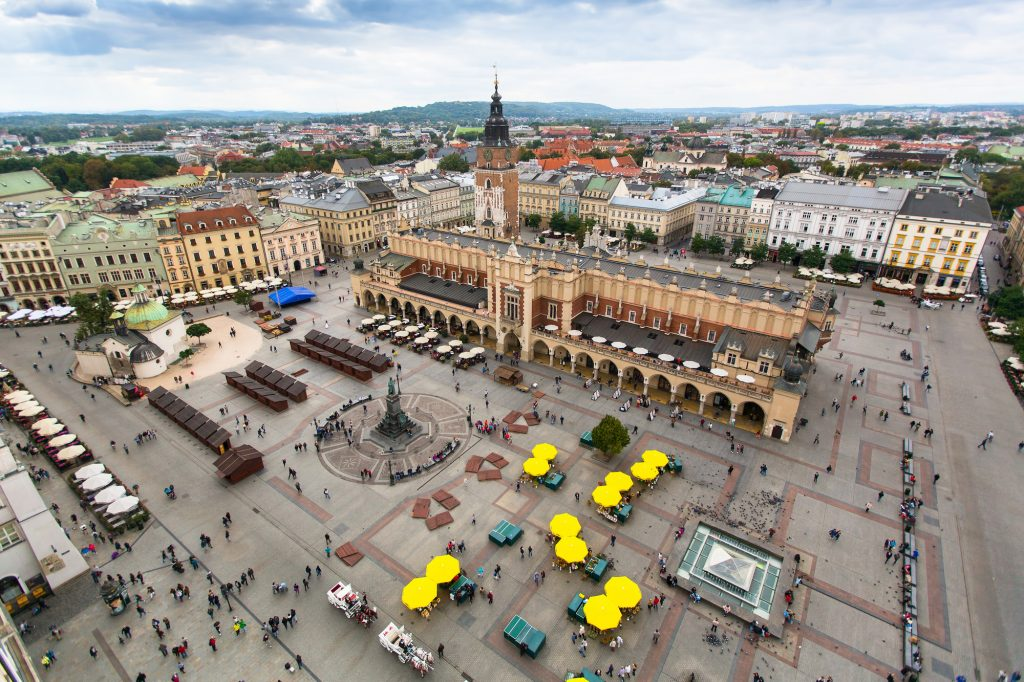Can you tell me more about the history of the Cloth Hall? Certainly! The Cloth Hall, or Sukiennice, in the heart of Krakow's Main Market Square, dates back to the Renaissance period and was once a major center of international trade. Merchants from across Europe gathered here to sell their wares, particularly textiles. The hall was reconstructed in the 16th century, adding many of its ornamental elements and showcases today, including its arcades and upper gallery, which now houses part of the National Museum. 